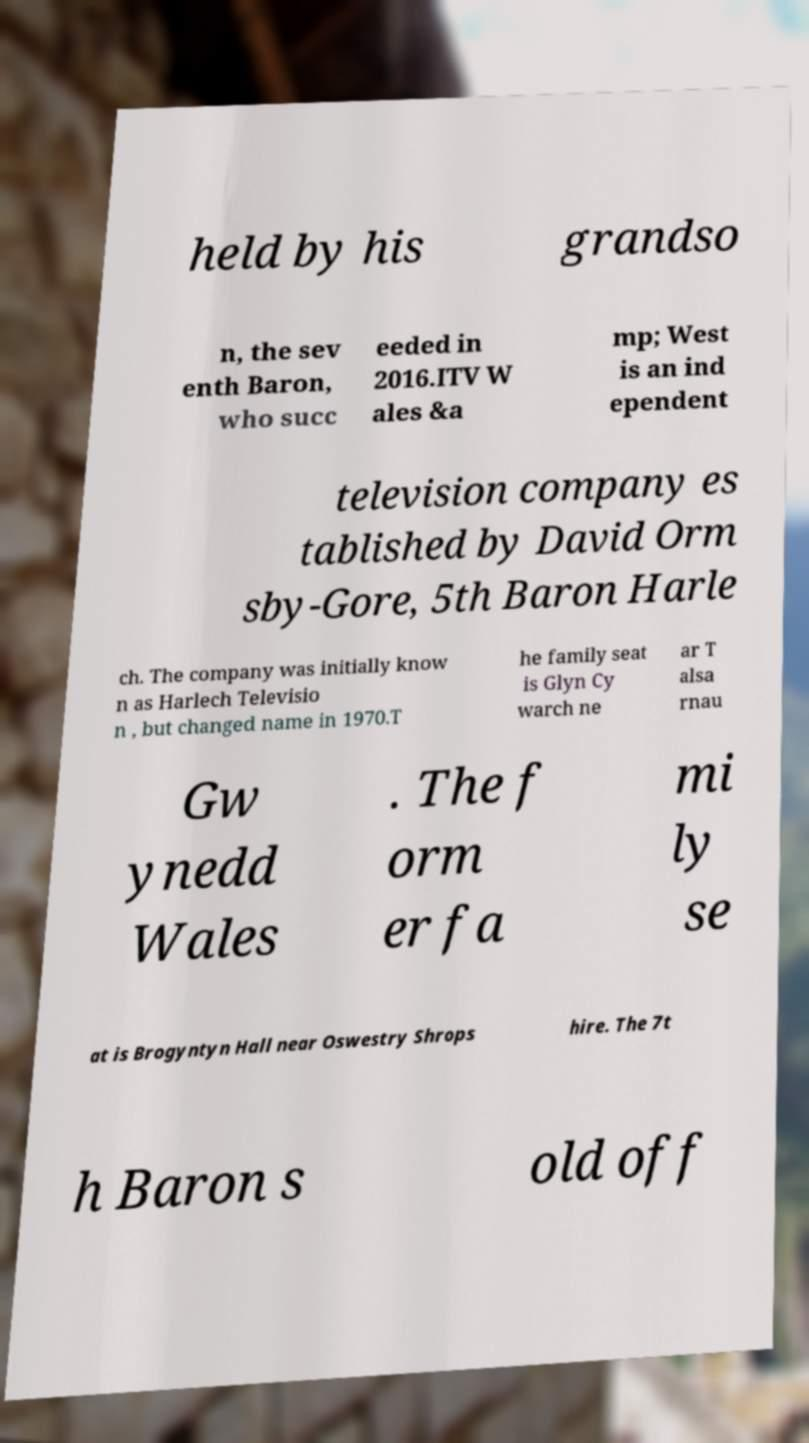Can you accurately transcribe the text from the provided image for me? held by his grandso n, the sev enth Baron, who succ eeded in 2016.ITV W ales &a mp; West is an ind ependent television company es tablished by David Orm sby-Gore, 5th Baron Harle ch. The company was initially know n as Harlech Televisio n , but changed name in 1970.T he family seat is Glyn Cy warch ne ar T alsa rnau Gw ynedd Wales . The f orm er fa mi ly se at is Brogyntyn Hall near Oswestry Shrops hire. The 7t h Baron s old off 